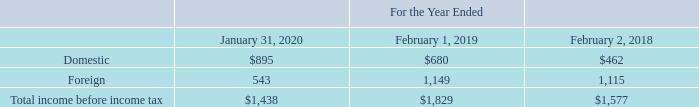P. Income Taxes
The domestic and foreign components of income before income tax for the periods presented were as follows (table in millions):
Which years does the table provide information for the domestic and foreign components of income before income tax? 2020, 2019, 2018. What was the domestic income in 2020?
Answer scale should be: million. 895. What was the foreign income in 2018?
Answer scale should be: million. 1,115. What was the change in Foreign income between 2018 and 2019?
Answer scale should be: million. 1,149-1,115
Answer: 34. How many years did Domestic income exceed $500 million? 2020##2019
Answer: 2. What was the percentage change in the total income before income tax between 2019 and 2020?
Answer scale should be: percent. (1,438-1,829)/1,829
Answer: -21.38. 